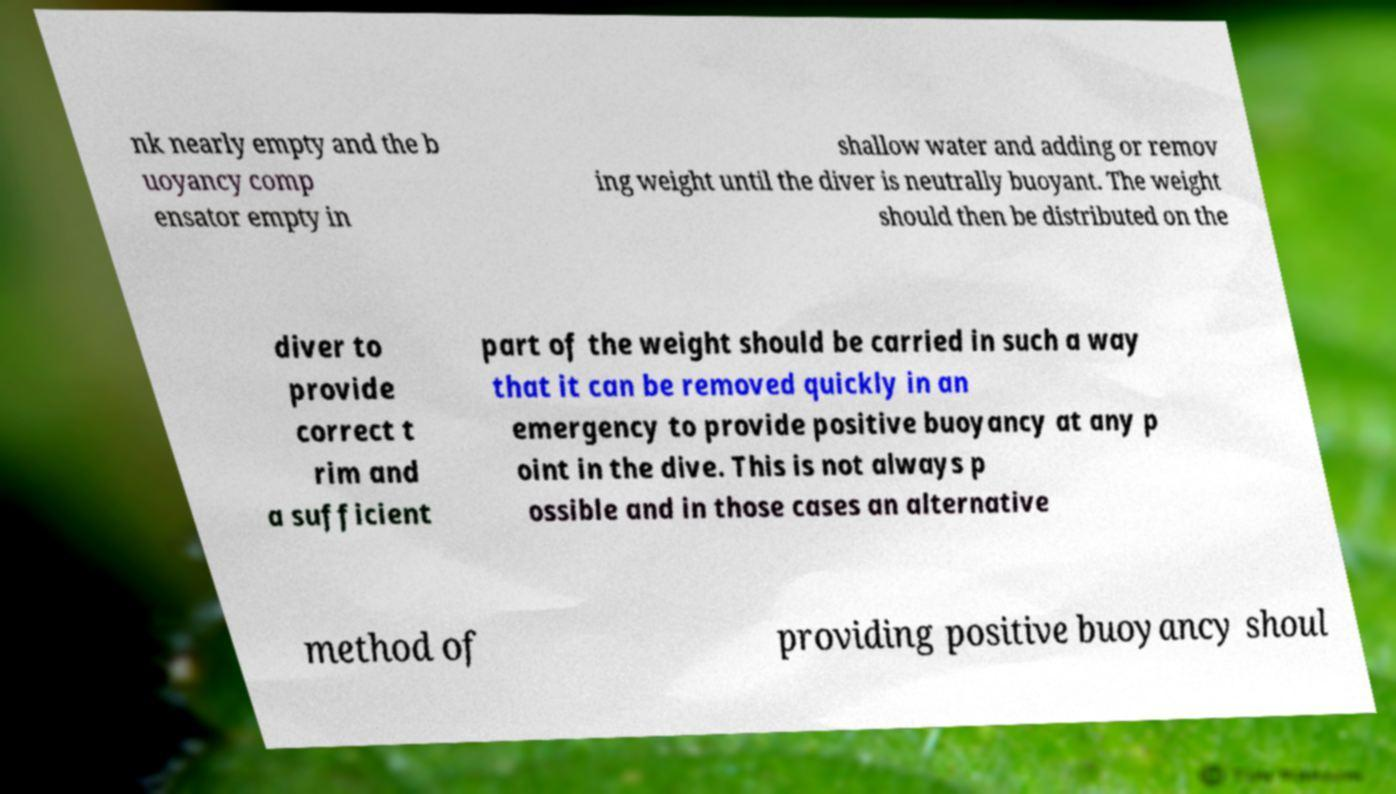I need the written content from this picture converted into text. Can you do that? nk nearly empty and the b uoyancy comp ensator empty in shallow water and adding or remov ing weight until the diver is neutrally buoyant. The weight should then be distributed on the diver to provide correct t rim and a sufficient part of the weight should be carried in such a way that it can be removed quickly in an emergency to provide positive buoyancy at any p oint in the dive. This is not always p ossible and in those cases an alternative method of providing positive buoyancy shoul 